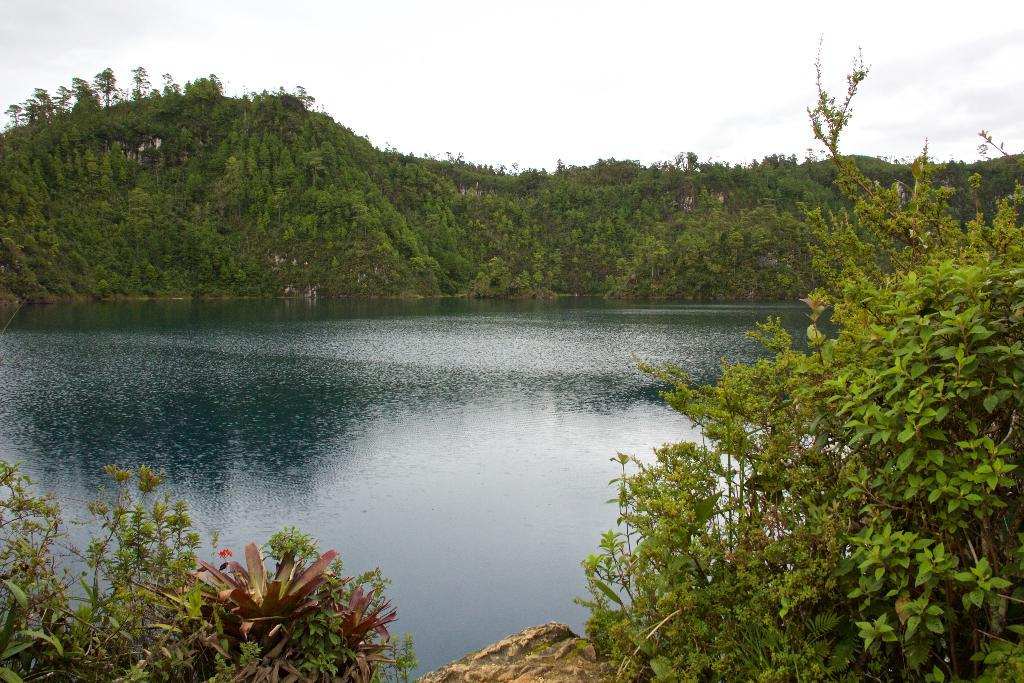What type of vegetation can be seen in the image? There are trees in the image. What natural feature is located in the middle of the trees? There is a river in the image, located in the middle of the trees. What is visible in the background of the image? There is a sky visible in the background of the image. What type of detail can be seen on the brake of the car in the image? There is no car or brake present in the image; it features trees and a river. What type of pipe is visible in the image? There is no pipe present in the image; it features trees, a river, and a sky. 